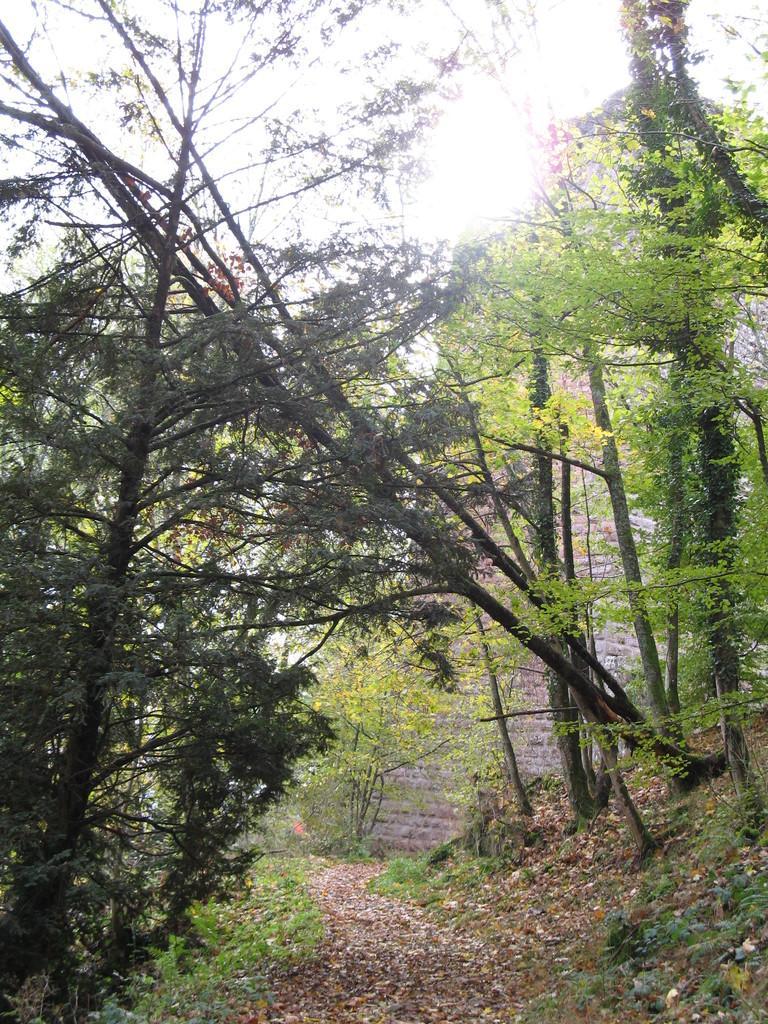Could you give a brief overview of what you see in this image? In the picture we can see a path with dried leaves and besides on the either sides we can see grass, plants and trees. 